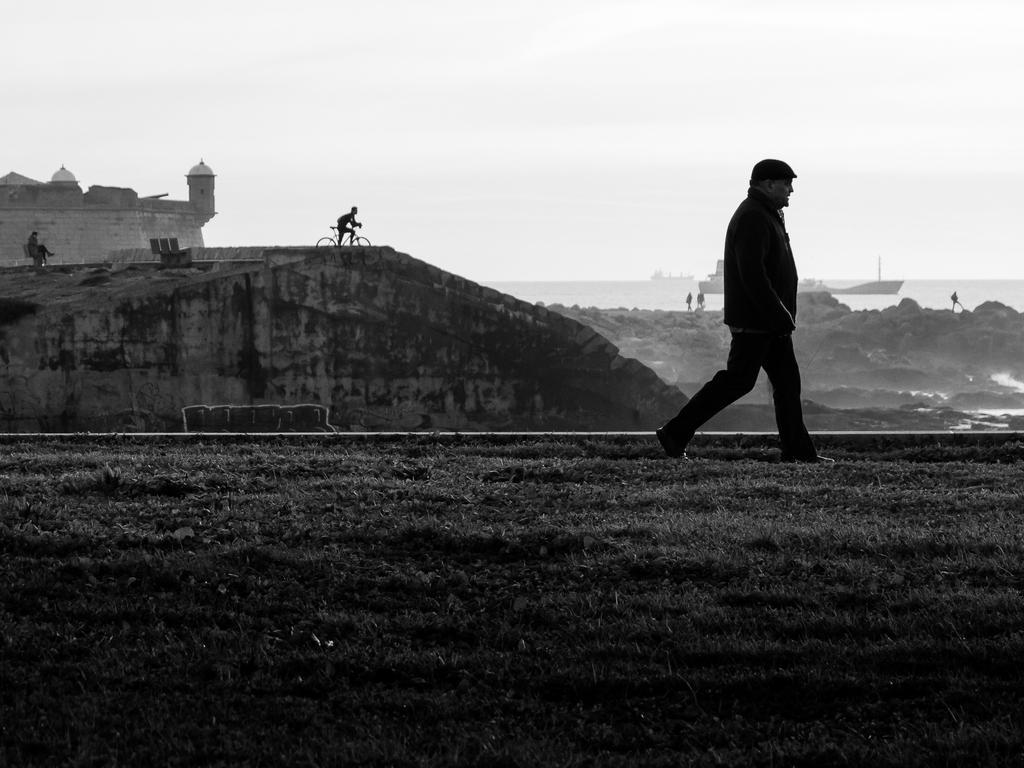Describe this image in one or two sentences. At the top of the image we can see fort, person sitting on the bench, person sitting on the bicycle, persons standing on the rocks near the sea, ships, sea and sky. At the bottom of the image we can see a person walking on the grass. 